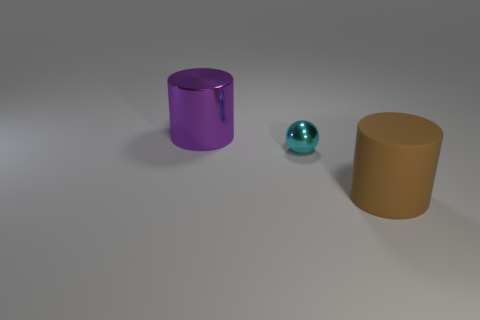Add 3 tiny brown metallic balls. How many objects exist? 6 Subtract all balls. How many objects are left? 2 Subtract 0 red balls. How many objects are left? 3 Subtract all balls. Subtract all big green cylinders. How many objects are left? 2 Add 1 cyan metal things. How many cyan metal things are left? 2 Add 3 large gray rubber spheres. How many large gray rubber spheres exist? 3 